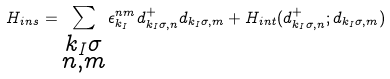Convert formula to latex. <formula><loc_0><loc_0><loc_500><loc_500>H _ { i n s } = \sum _ { \substack { k _ { I } \sigma \\ n , m } } \epsilon _ { k _ { I } } ^ { n m } d _ { k _ { I } \sigma , n } ^ { + } d _ { k _ { I } \sigma , m } + H _ { i n t } ( d _ { k _ { I } \sigma , n } ^ { + } ; d _ { k _ { I } \sigma , m } )</formula> 